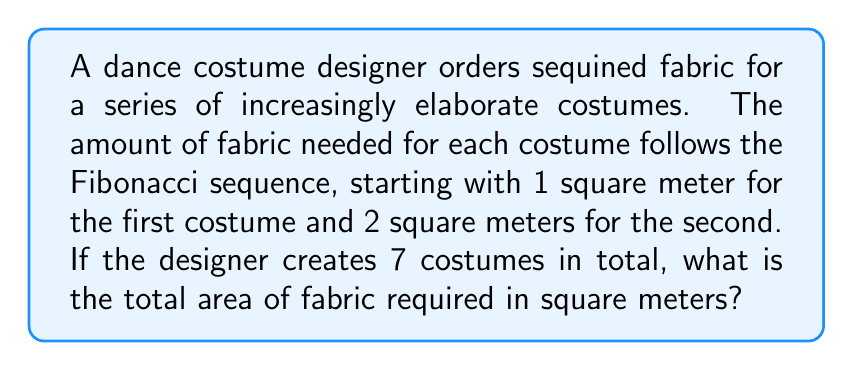Provide a solution to this math problem. Let's approach this step-by-step:

1) First, recall the Fibonacci sequence: Each number is the sum of the two preceding ones. It starts with 1, 1, 2, 3, 5, 8, 13, ...

2) In this case, we start with 1 and 2, so our sequence will be:
   1, 2, 3, 5, 8, 13, 21

3) We need to sum these 7 terms:

   $$S = 1 + 2 + 3 + 5 + 8 + 13 + 21$$

4) To calculate this sum efficiently, we can use the property of Fibonacci numbers that the sum of the first n Fibonacci numbers is equal to the (n+2)th Fibonacci number minus 1.

5) In our case, we want the sum of the first 7 terms, so we need the 9th Fibonacci number:
   1, 2, 3, 5, 8, 13, 21, 34, 55

6) The 9th Fibonacci number is 55.

7) Therefore, the sum is:

   $$S = 55 - 1 = 54$$

Thus, the total area of fabric required is 54 square meters.
Answer: 54 square meters 